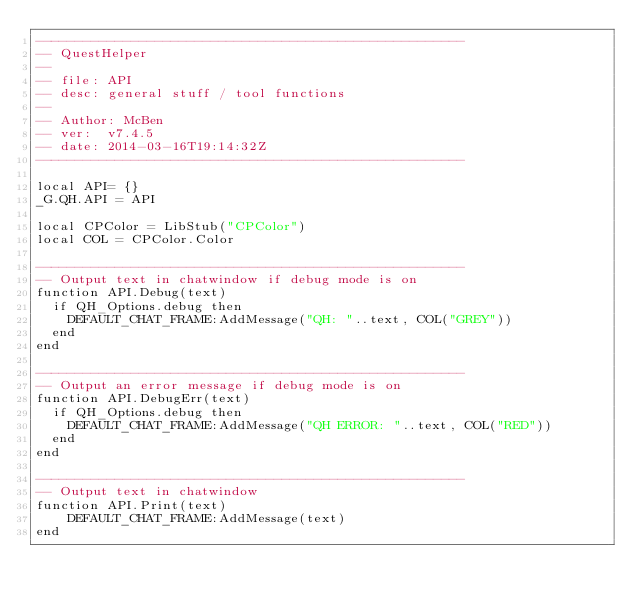<code> <loc_0><loc_0><loc_500><loc_500><_Lua_>------------------------------------------------------
-- QuestHelper
--
-- file: API
-- desc: general stuff / tool functions
--
-- Author: McBen
-- ver:  v7.4.5
-- date: 2014-03-16T19:14:32Z
------------------------------------------------------

local API= {}
_G.QH.API = API

local CPColor = LibStub("CPColor")
local COL = CPColor.Color

------------------------------------------------------
-- Output text in chatwindow if debug mode is on
function API.Debug(text)
  if QH_Options.debug then
    DEFAULT_CHAT_FRAME:AddMessage("QH: "..text, COL("GREY"))
  end
end

------------------------------------------------------
-- Output an error message if debug mode is on
function API.DebugErr(text)
  if QH_Options.debug then
    DEFAULT_CHAT_FRAME:AddMessage("QH ERROR: "..text, COL("RED"))
  end
end

------------------------------------------------------
-- Output text in chatwindow
function API.Print(text)
    DEFAULT_CHAT_FRAME:AddMessage(text)
end


</code> 